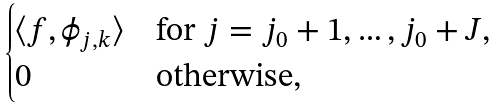<formula> <loc_0><loc_0><loc_500><loc_500>\begin{cases} \langle f , \phi _ { j , k } \rangle & \text {for $j=j_{0}+1,\dots,j_{0}+J$,} \\ 0 & \text {otherwise,} \end{cases}</formula> 